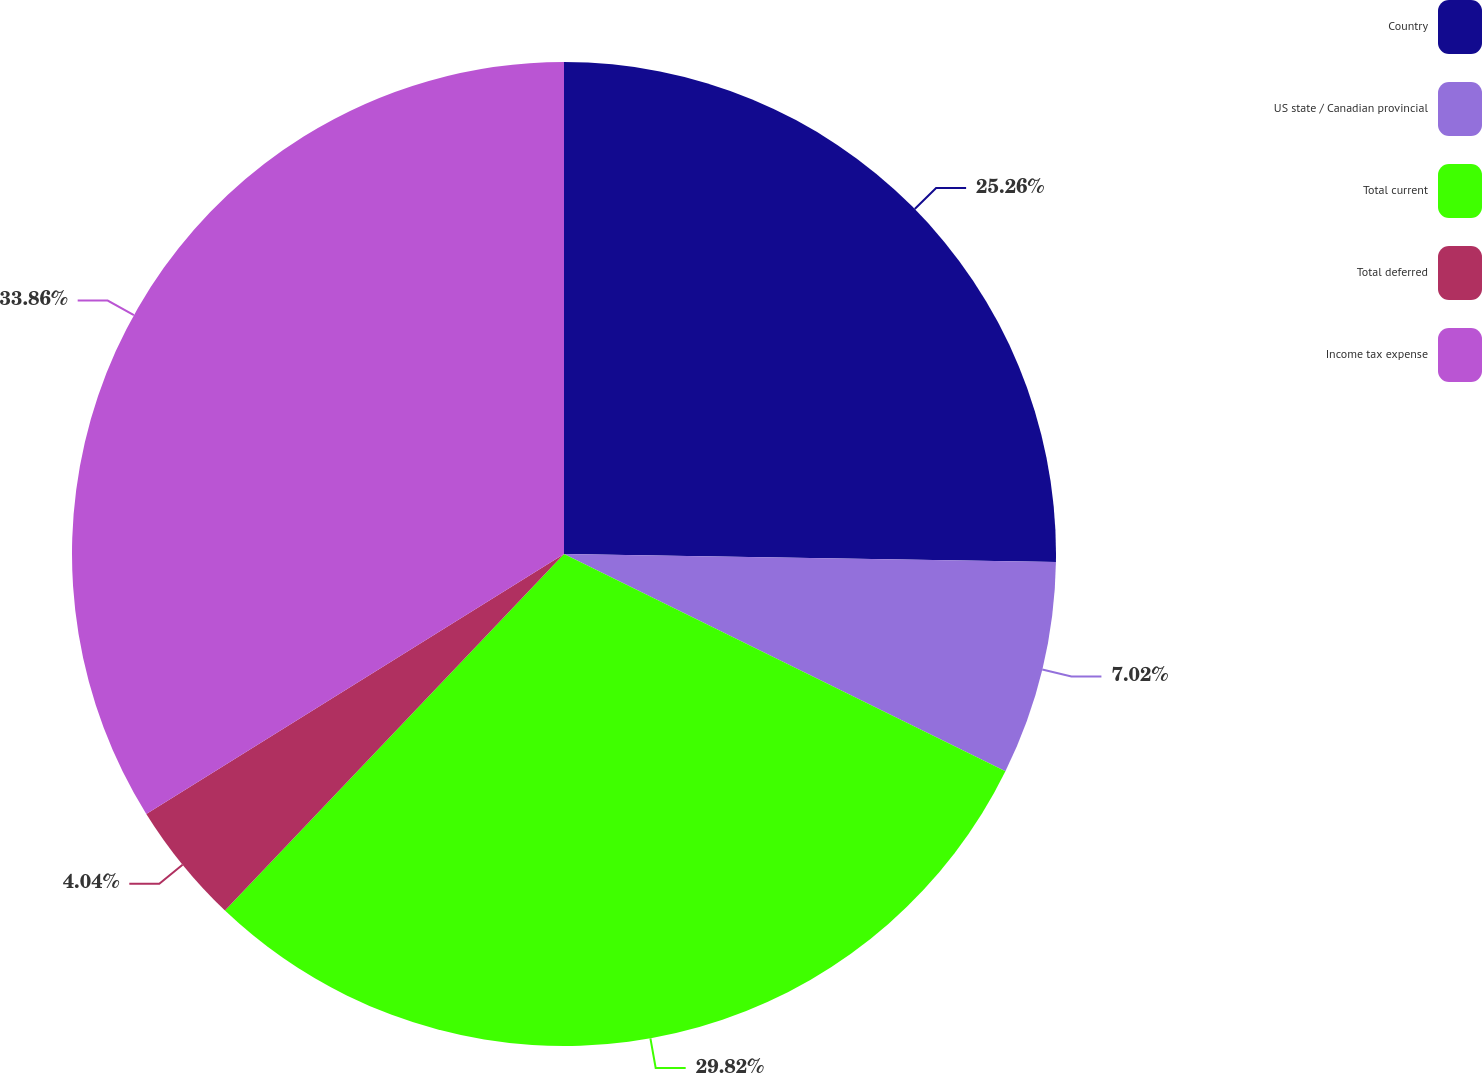<chart> <loc_0><loc_0><loc_500><loc_500><pie_chart><fcel>Country<fcel>US state / Canadian provincial<fcel>Total current<fcel>Total deferred<fcel>Income tax expense<nl><fcel>25.26%<fcel>7.02%<fcel>29.82%<fcel>4.04%<fcel>33.86%<nl></chart> 